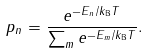Convert formula to latex. <formula><loc_0><loc_0><loc_500><loc_500>p _ { n } = \frac { e ^ { - E _ { n } / k _ { \text {B} } T } } { \sum _ { m } e ^ { - E _ { m } / k _ { \text {B} } T } } .</formula> 